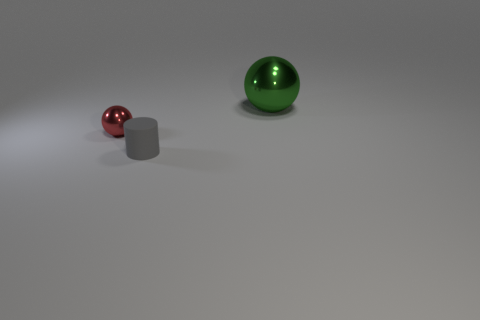Are there any other large yellow shiny objects that have the same shape as the large thing?
Your answer should be very brief. No. There is a red shiny object that is the same size as the matte cylinder; what shape is it?
Provide a succinct answer. Sphere. Are there any big metal objects that are in front of the shiny sphere that is in front of the sphere to the right of the small gray rubber object?
Your response must be concise. No. Is there a cylinder of the same size as the red metal object?
Your answer should be very brief. Yes. There is a metal sphere that is on the left side of the green metal thing; what is its size?
Offer a very short reply. Small. There is a sphere behind the shiny thing that is in front of the ball that is behind the red object; what color is it?
Your answer should be compact. Green. The metallic object that is to the left of the tiny object that is to the right of the tiny shiny ball is what color?
Provide a short and direct response. Red. Is the number of small matte things to the left of the big thing greater than the number of cylinders behind the red ball?
Ensure brevity in your answer.  Yes. Is the material of the ball in front of the big green shiny ball the same as the sphere on the right side of the cylinder?
Make the answer very short. Yes. There is a large thing; are there any tiny gray rubber objects to the right of it?
Ensure brevity in your answer.  No. 